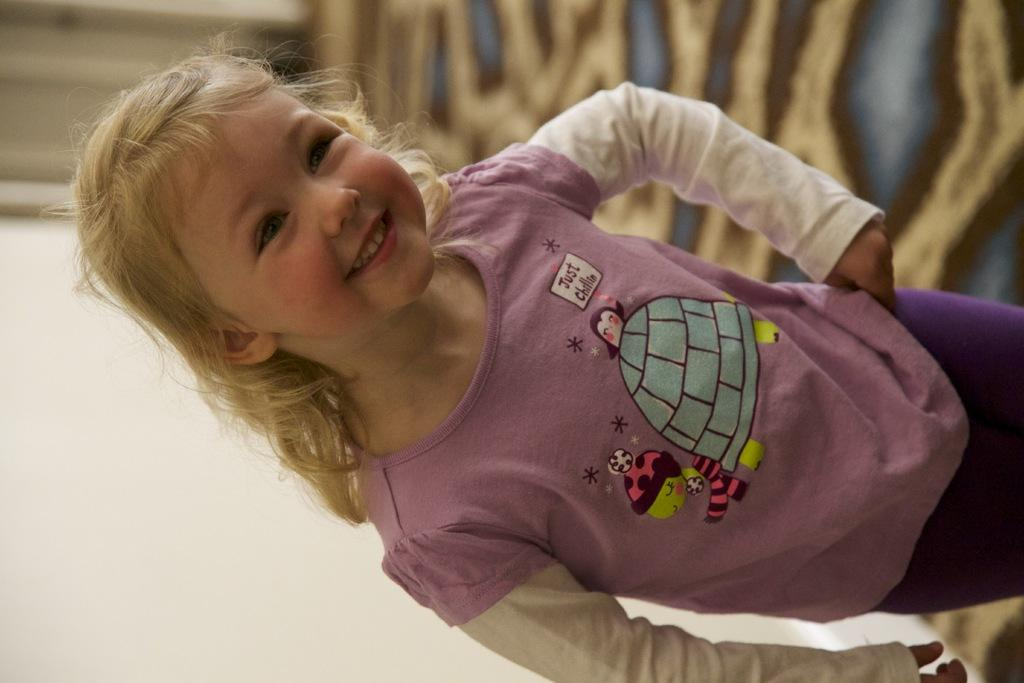What is the main subject of the image? There is a person standing in the image. What is the person wearing? The person is wearing a purple and white color dress. What can be seen in the background of the image? There is a wall in the background of the image. How many mice are running around the person's feet in the image? There are no mice present in the image. What type of carriage is visible in the background of the image? There is no carriage present in the image; only a wall can be seen in the background. 